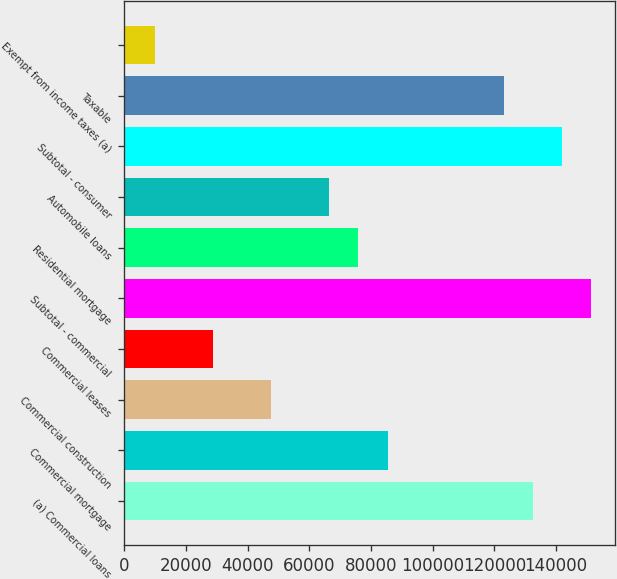Convert chart to OTSL. <chart><loc_0><loc_0><loc_500><loc_500><bar_chart><fcel>(a) Commercial loans<fcel>Commercial mortgage<fcel>Commercial construction<fcel>Commercial leases<fcel>Subtotal - commercial<fcel>Residential mortgage<fcel>Automobile loans<fcel>Subtotal - consumer<fcel>Taxable<fcel>Exempt from income taxes (a)<nl><fcel>132560<fcel>85358.7<fcel>47597.5<fcel>28716.9<fcel>151441<fcel>75918.4<fcel>66478.1<fcel>142000<fcel>123120<fcel>9836.3<nl></chart> 